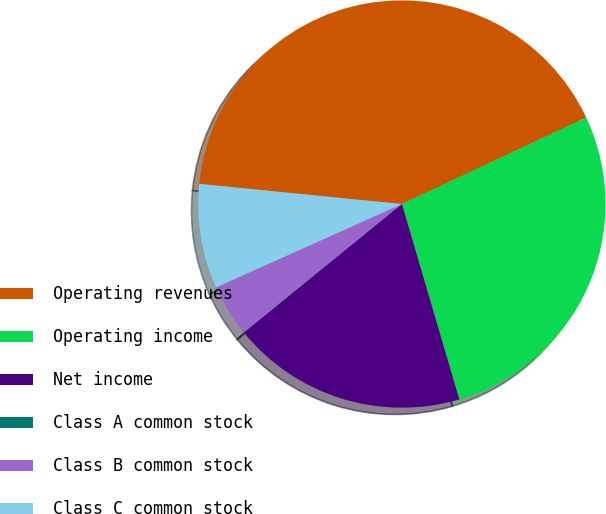Convert chart to OTSL. <chart><loc_0><loc_0><loc_500><loc_500><pie_chart><fcel>Operating revenues<fcel>Operating income<fcel>Net income<fcel>Class A common stock<fcel>Class B common stock<fcel>Class C common stock<nl><fcel>41.43%<fcel>27.44%<fcel>18.68%<fcel>0.01%<fcel>4.15%<fcel>8.29%<nl></chart> 